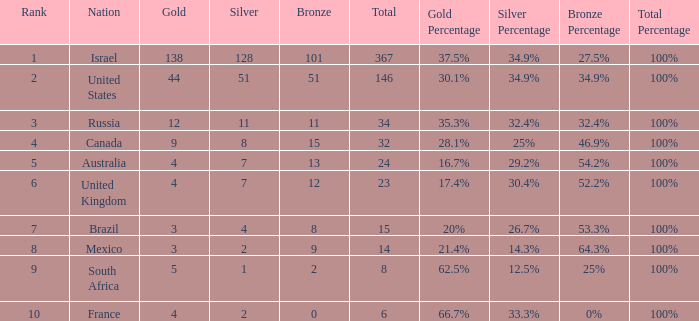What is the gold medal count for the country with a total greater than 32 and more than 128 silvers? None. 